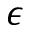<formula> <loc_0><loc_0><loc_500><loc_500>\epsilon</formula> 